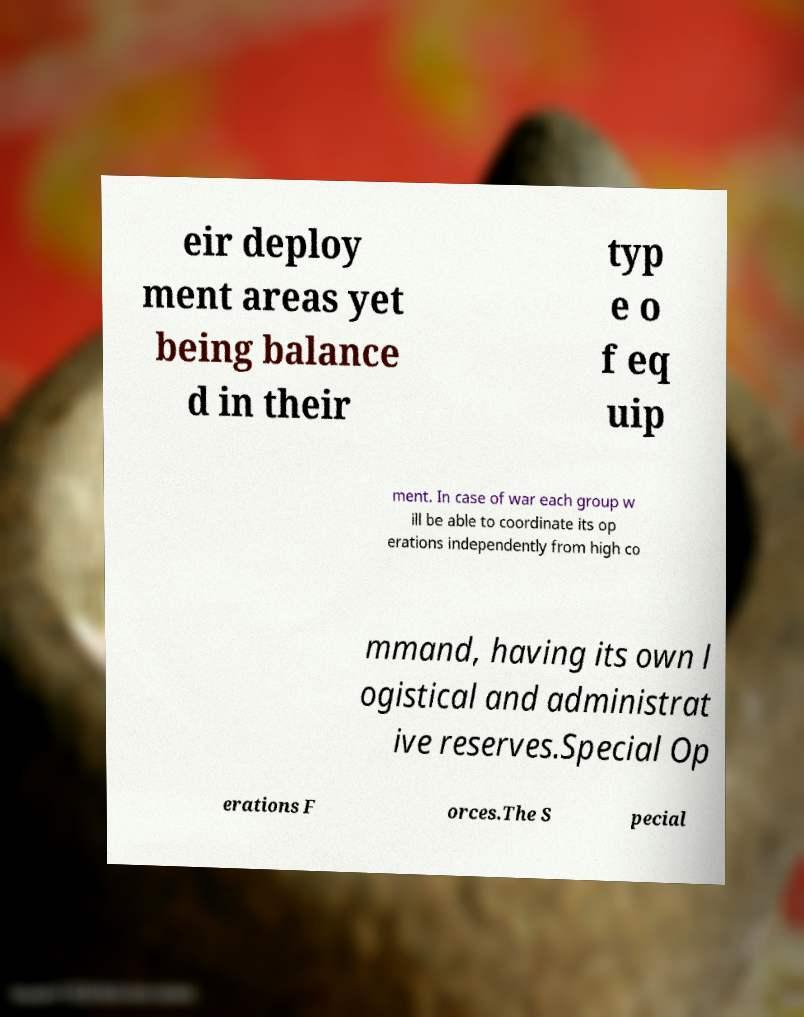Can you read and provide the text displayed in the image?This photo seems to have some interesting text. Can you extract and type it out for me? eir deploy ment areas yet being balance d in their typ e o f eq uip ment. In case of war each group w ill be able to coordinate its op erations independently from high co mmand, having its own l ogistical and administrat ive reserves.Special Op erations F orces.The S pecial 